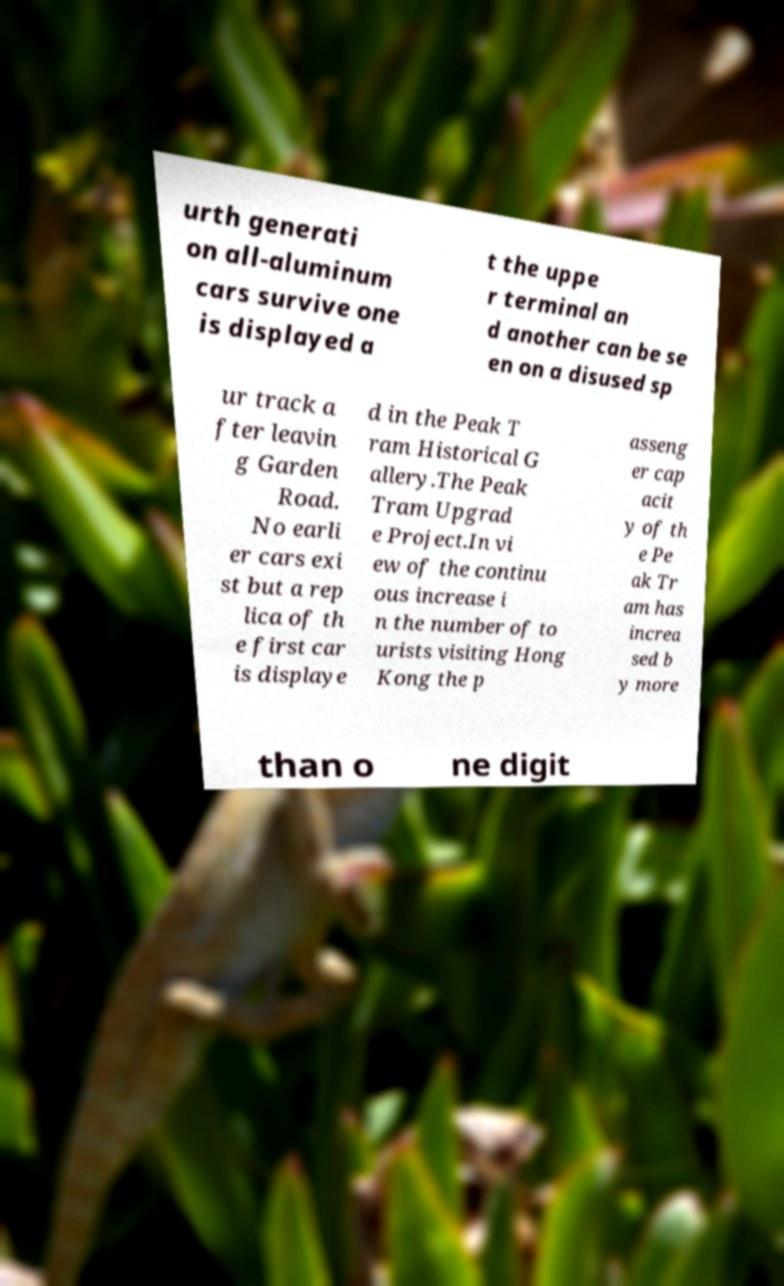I need the written content from this picture converted into text. Can you do that? urth generati on all-aluminum cars survive one is displayed a t the uppe r terminal an d another can be se en on a disused sp ur track a fter leavin g Garden Road. No earli er cars exi st but a rep lica of th e first car is displaye d in the Peak T ram Historical G allery.The Peak Tram Upgrad e Project.In vi ew of the continu ous increase i n the number of to urists visiting Hong Kong the p asseng er cap acit y of th e Pe ak Tr am has increa sed b y more than o ne digit 